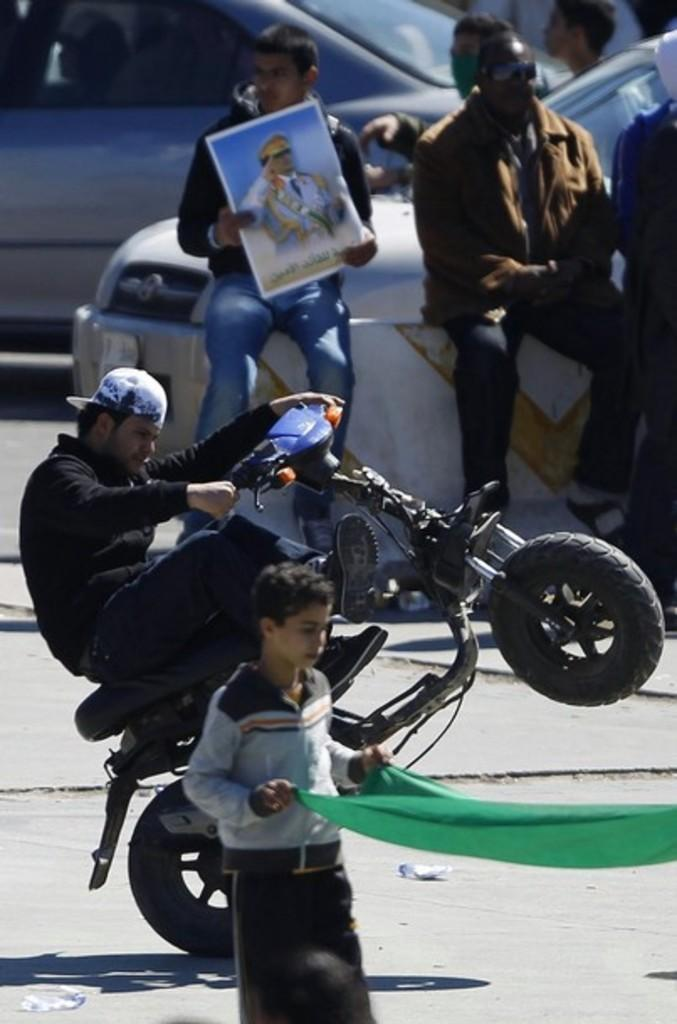What is the man in the image doing? The man is riding a bike in the image. Where is the man riding the bike? The man is on the road. Who else is present in the image besides the man on the bike? There is a boy standing in the image, and a group of people are standing in the image. What else can be seen on the road in the image? There is a car traveling on the road in the image. What type of cord is being used to control the movements of the bike in the image? There is no cord present in the image, and the bike is being ridden by the man, not controlled by a cord. 